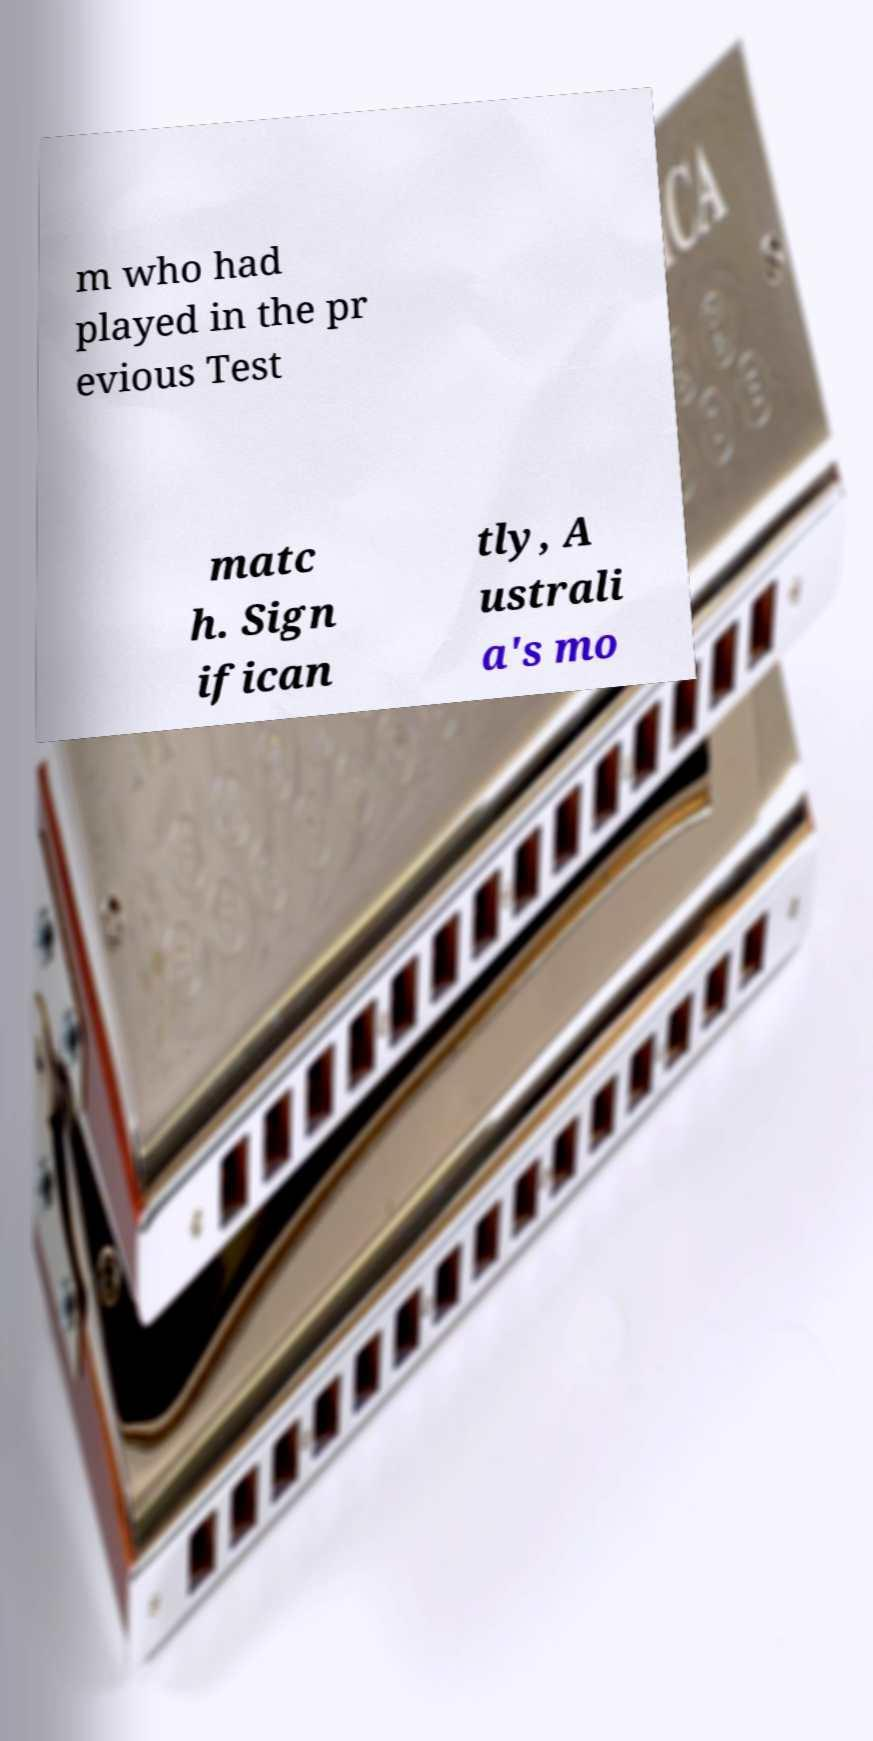I need the written content from this picture converted into text. Can you do that? m who had played in the pr evious Test matc h. Sign ifican tly, A ustrali a's mo 